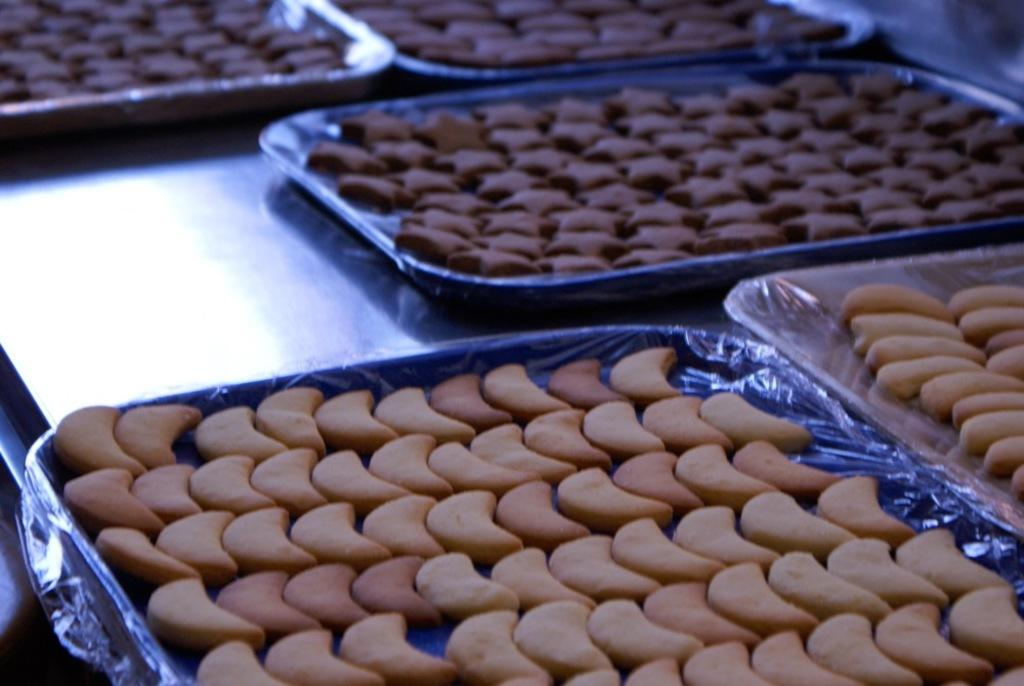What type of food can be seen in the image? There are biscuits in the image. How are the biscuits arranged or contained in the image? The biscuits are in a tray. What type of cover is placed on the celery in the image? There is no celery or cover present in the image; it only features biscuits in a tray. 